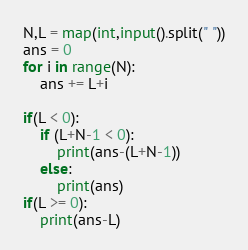<code> <loc_0><loc_0><loc_500><loc_500><_Python_>N,L = map(int,input().split(" "))
ans = 0
for i in range(N):
    ans += L+i

if(L < 0):
    if (L+N-1 < 0):
        print(ans-(L+N-1))
    else:
        print(ans)
if(L >= 0):
    print(ans-L)
</code> 